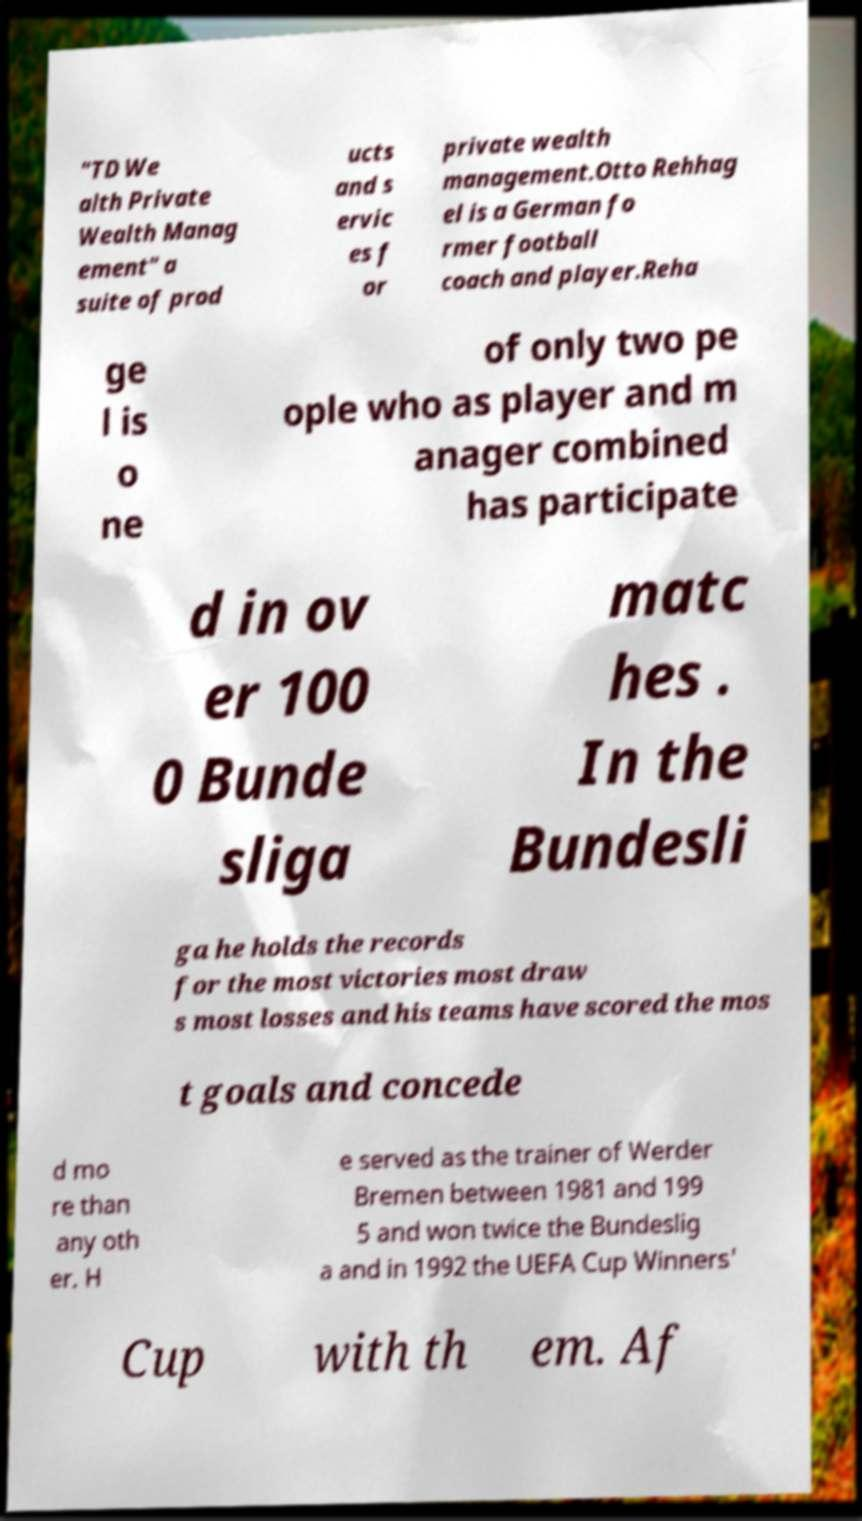Could you extract and type out the text from this image? "TD We alth Private Wealth Manag ement" a suite of prod ucts and s ervic es f or private wealth management.Otto Rehhag el is a German fo rmer football coach and player.Reha ge l is o ne of only two pe ople who as player and m anager combined has participate d in ov er 100 0 Bunde sliga matc hes . In the Bundesli ga he holds the records for the most victories most draw s most losses and his teams have scored the mos t goals and concede d mo re than any oth er. H e served as the trainer of Werder Bremen between 1981 and 199 5 and won twice the Bundeslig a and in 1992 the UEFA Cup Winners' Cup with th em. Af 